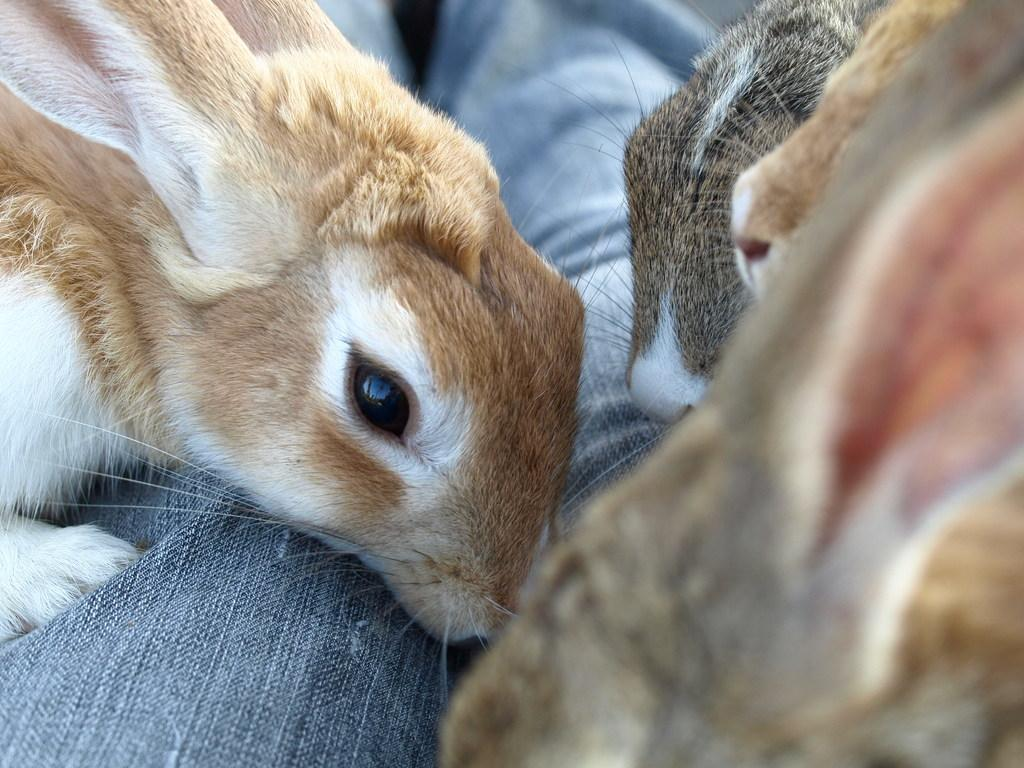What type of animals are present in the image? There are rabbits in the image. What colors are the rabbits? The rabbits are white, pale brown, and gray in color. What else can be seen in the image besides the rabbits? There is a cloth visible in the image. What type of tax is being discussed in the image? There is no discussion of tax in the image; it features rabbits and a cloth. Can you see a horse in the image? No, there is no horse present in the image. 